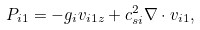Convert formula to latex. <formula><loc_0><loc_0><loc_500><loc_500>P _ { i 1 } = - g _ { i } v _ { i 1 z } + c _ { s i } ^ { 2 } \nabla \cdot v _ { i 1 } ,</formula> 